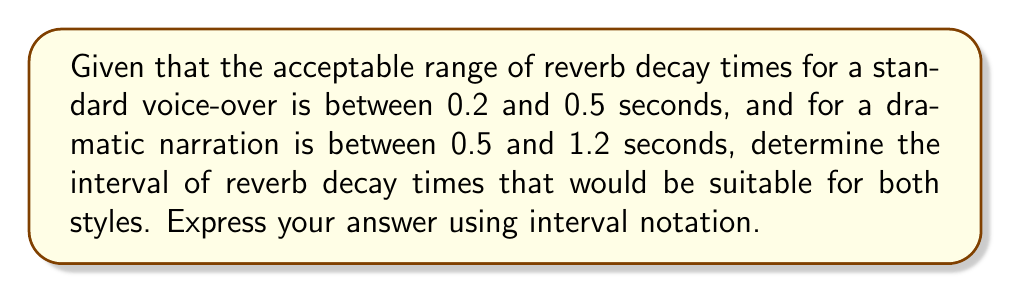Show me your answer to this math problem. To solve this problem, we need to find the intersection of the two given intervals. Let's approach this step-by-step:

1. Standard voice-over range: $[0.2, 0.5]$
2. Dramatic narration range: $[0.5, 1.2]$

3. To find the interval that works for both styles, we need to identify the overlap between these two ranges.

4. The lower bound of the overlapping interval will be the maximum of the two lower bounds:
   $\max(0.2, 0.5) = 0.5$

5. The upper bound of the overlapping interval will be the minimum of the two upper bounds:
   $\min(0.5, 1.2) = 0.5$

6. Therefore, the overlapping interval is $[0.5, 0.5]$, which is actually a single point.

7. In interval notation, when the lower and upper bounds are the same, we can express this as a single point using curly braces: $\{0.5\}$

This means that a reverb decay time of exactly 0.5 seconds would be suitable for both standard voice-over and dramatic narration styles.
Answer: $\{0.5\}$ 